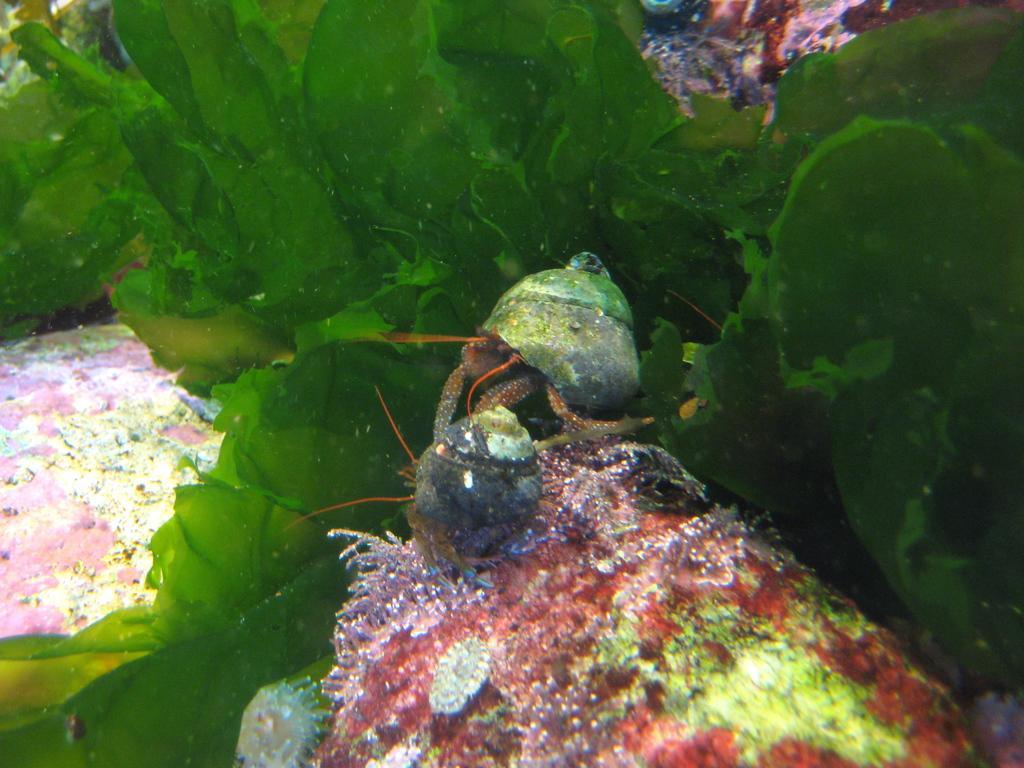How would you summarize this image in a sentence or two? In this picture, we see the aquatic plants and animals. This picture might be clicked in the aquarium. 